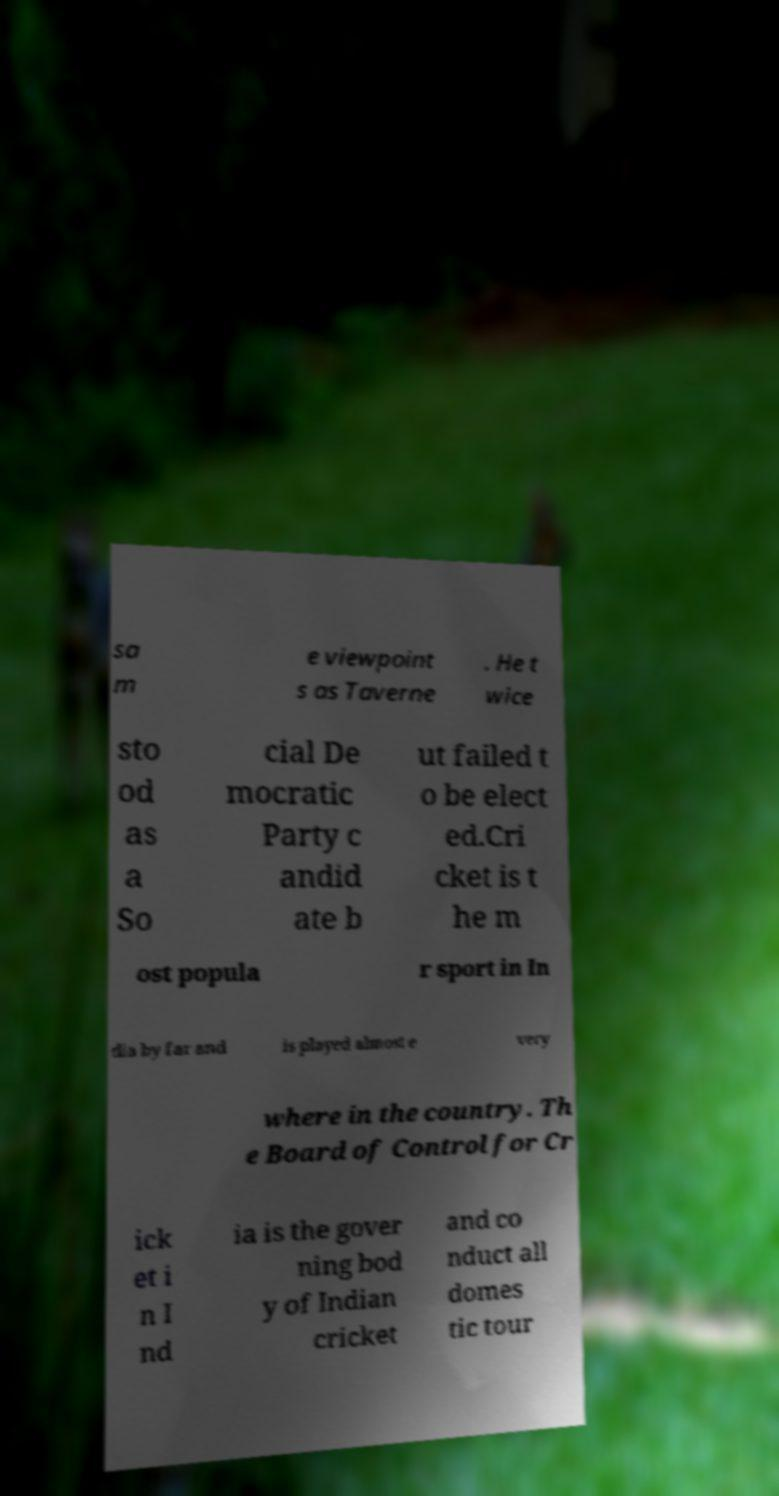Could you extract and type out the text from this image? sa m e viewpoint s as Taverne . He t wice sto od as a So cial De mocratic Party c andid ate b ut failed t o be elect ed.Cri cket is t he m ost popula r sport in In dia by far and is played almost e very where in the country. Th e Board of Control for Cr ick et i n I nd ia is the gover ning bod y of Indian cricket and co nduct all domes tic tour 